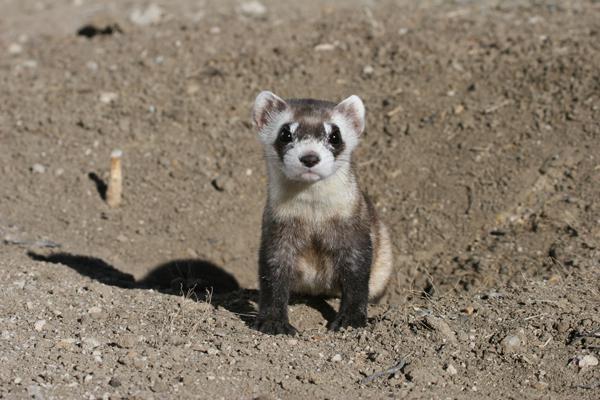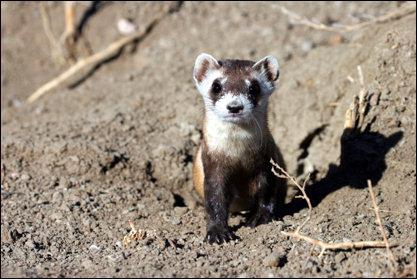The first image is the image on the left, the second image is the image on the right. Considering the images on both sides, is "The body of at least two ferrets are facing directly at the camera" valid? Answer yes or no. Yes. The first image is the image on the left, the second image is the image on the right. Examine the images to the left and right. Is the description "There is a pair of ferrets in one image." accurate? Answer yes or no. No. 